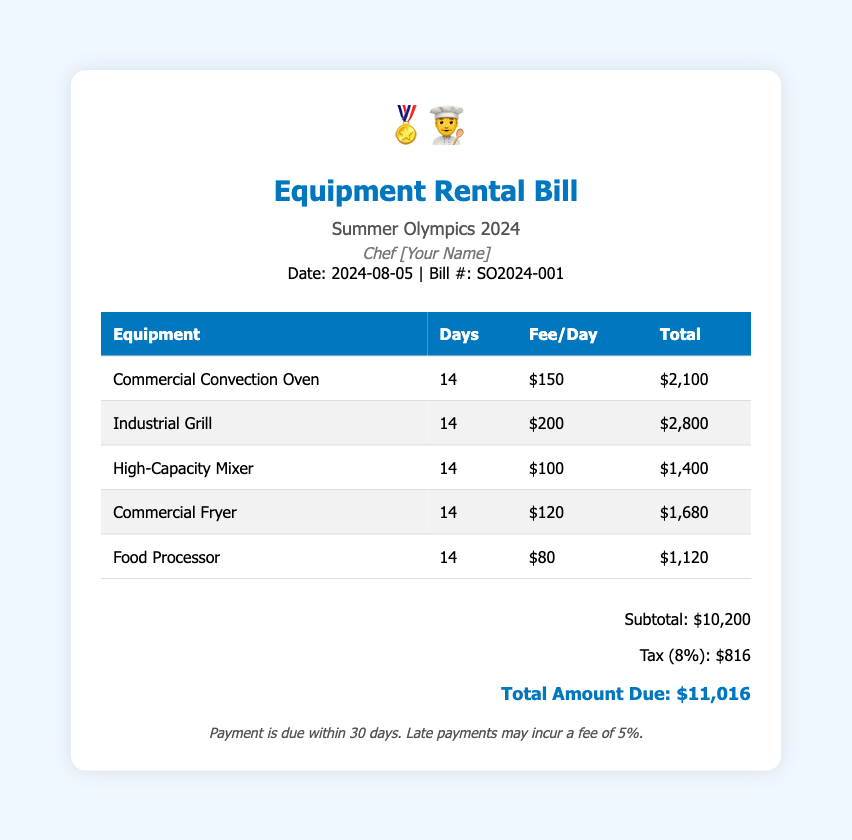What is the date of the bill? The date of the bill is mentioned in the document as "2024-08-05."
Answer: 2024-08-05 How many days of rental are charged for each equipment? The document states that all pieces of equipment are rented for 14 days.
Answer: 14 What is the total fee for the Commercial Fryer? The total fee for the Commercial Fryer is calculated as $120 per day multiplied by 14 days, which yields $1,680.
Answer: $1,680 What is the subtotal amount before tax? The subtotal amount is explicitly listed in the document as $10,200 before tax.
Answer: $10,200 What is the tax rate applied to the bill? The tax rate mentioned in the document is 8%.
Answer: 8% What is the total amount due? The total amount due after tax is provided in the document as $11,016.
Answer: $11,016 Which piece of equipment has the highest rental fee per day? The Industrial Grill is noted as having the highest rental fee per day at $200.
Answer: Industrial Grill When is the payment due? The payment terms specify that payment is due within 30 days.
Answer: 30 days What is the bill number? The bill number is indicated as SO2024-001 in the document.
Answer: SO2024-001 